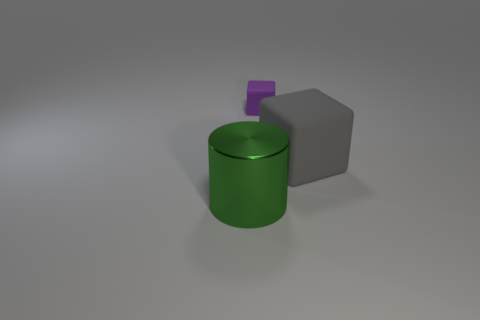Can you describe the spatial arrangement of the objects in the image? Certainly, in the image, we have three objects arrayed with a sense of depth. To the fore, there is a shiny green cylinder that seems closer to us due to its size and the way light plays on its surface. Being set back a little on the right is a matte gray cube, giving a subtle contrast with its dull finish. Lastly, there's a small purple cube sitting atop the green cylinder, its vibrant color catching the eye and adding a touch of whimsy to the composition. 